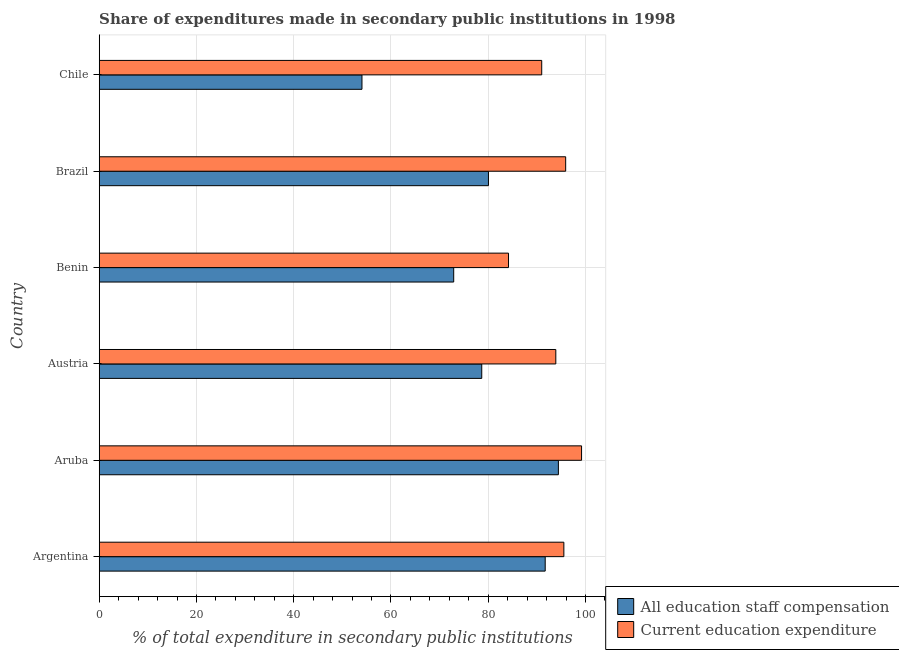How many groups of bars are there?
Your response must be concise. 6. Are the number of bars per tick equal to the number of legend labels?
Provide a short and direct response. Yes. Are the number of bars on each tick of the Y-axis equal?
Make the answer very short. Yes. How many bars are there on the 6th tick from the top?
Offer a very short reply. 2. What is the label of the 3rd group of bars from the top?
Provide a succinct answer. Benin. What is the expenditure in staff compensation in Argentina?
Offer a terse response. 91.71. Across all countries, what is the maximum expenditure in education?
Make the answer very short. 99.19. Across all countries, what is the minimum expenditure in education?
Keep it short and to the point. 84.17. In which country was the expenditure in staff compensation maximum?
Offer a terse response. Aruba. In which country was the expenditure in education minimum?
Your response must be concise. Benin. What is the total expenditure in education in the graph?
Your answer should be very brief. 559.72. What is the difference between the expenditure in education in Benin and that in Brazil?
Offer a very short reply. -11.75. What is the difference between the expenditure in education in Benin and the expenditure in staff compensation in Aruba?
Provide a short and direct response. -10.26. What is the average expenditure in staff compensation per country?
Offer a terse response. 78.63. What is the difference between the expenditure in education and expenditure in staff compensation in Aruba?
Offer a very short reply. 4.76. In how many countries, is the expenditure in staff compensation greater than 40 %?
Ensure brevity in your answer.  6. What is the ratio of the expenditure in staff compensation in Aruba to that in Chile?
Your answer should be compact. 1.75. Is the expenditure in education in Argentina less than that in Chile?
Your answer should be very brief. No. What is the difference between the highest and the second highest expenditure in staff compensation?
Give a very brief answer. 2.71. What is the difference between the highest and the lowest expenditure in staff compensation?
Provide a short and direct response. 40.39. In how many countries, is the expenditure in staff compensation greater than the average expenditure in staff compensation taken over all countries?
Provide a short and direct response. 4. What does the 1st bar from the top in Austria represents?
Give a very brief answer. Current education expenditure. What does the 1st bar from the bottom in Benin represents?
Make the answer very short. All education staff compensation. How many bars are there?
Your answer should be very brief. 12. Are all the bars in the graph horizontal?
Your answer should be very brief. Yes. Are the values on the major ticks of X-axis written in scientific E-notation?
Offer a very short reply. No. Does the graph contain any zero values?
Keep it short and to the point. No. Does the graph contain grids?
Your answer should be very brief. Yes. Where does the legend appear in the graph?
Your answer should be compact. Bottom right. What is the title of the graph?
Offer a terse response. Share of expenditures made in secondary public institutions in 1998. Does "Diarrhea" appear as one of the legend labels in the graph?
Ensure brevity in your answer.  No. What is the label or title of the X-axis?
Ensure brevity in your answer.  % of total expenditure in secondary public institutions. What is the label or title of the Y-axis?
Offer a terse response. Country. What is the % of total expenditure in secondary public institutions of All education staff compensation in Argentina?
Provide a succinct answer. 91.71. What is the % of total expenditure in secondary public institutions of Current education expenditure in Argentina?
Your answer should be very brief. 95.55. What is the % of total expenditure in secondary public institutions of All education staff compensation in Aruba?
Keep it short and to the point. 94.42. What is the % of total expenditure in secondary public institutions of Current education expenditure in Aruba?
Make the answer very short. 99.19. What is the % of total expenditure in secondary public institutions in All education staff compensation in Austria?
Make the answer very short. 78.67. What is the % of total expenditure in secondary public institutions of Current education expenditure in Austria?
Your answer should be very brief. 93.9. What is the % of total expenditure in secondary public institutions of All education staff compensation in Benin?
Give a very brief answer. 72.9. What is the % of total expenditure in secondary public institutions of Current education expenditure in Benin?
Provide a short and direct response. 84.17. What is the % of total expenditure in secondary public institutions in All education staff compensation in Brazil?
Provide a succinct answer. 80.04. What is the % of total expenditure in secondary public institutions of Current education expenditure in Brazil?
Ensure brevity in your answer.  95.92. What is the % of total expenditure in secondary public institutions in All education staff compensation in Chile?
Make the answer very short. 54.03. What is the % of total expenditure in secondary public institutions of Current education expenditure in Chile?
Your answer should be very brief. 91. Across all countries, what is the maximum % of total expenditure in secondary public institutions of All education staff compensation?
Offer a very short reply. 94.42. Across all countries, what is the maximum % of total expenditure in secondary public institutions in Current education expenditure?
Provide a succinct answer. 99.19. Across all countries, what is the minimum % of total expenditure in secondary public institutions of All education staff compensation?
Your answer should be compact. 54.03. Across all countries, what is the minimum % of total expenditure in secondary public institutions in Current education expenditure?
Offer a terse response. 84.17. What is the total % of total expenditure in secondary public institutions of All education staff compensation in the graph?
Offer a terse response. 471.77. What is the total % of total expenditure in secondary public institutions in Current education expenditure in the graph?
Your answer should be very brief. 559.72. What is the difference between the % of total expenditure in secondary public institutions in All education staff compensation in Argentina and that in Aruba?
Provide a short and direct response. -2.71. What is the difference between the % of total expenditure in secondary public institutions in Current education expenditure in Argentina and that in Aruba?
Make the answer very short. -3.64. What is the difference between the % of total expenditure in secondary public institutions of All education staff compensation in Argentina and that in Austria?
Your answer should be very brief. 13.05. What is the difference between the % of total expenditure in secondary public institutions in Current education expenditure in Argentina and that in Austria?
Provide a short and direct response. 1.65. What is the difference between the % of total expenditure in secondary public institutions of All education staff compensation in Argentina and that in Benin?
Make the answer very short. 18.82. What is the difference between the % of total expenditure in secondary public institutions in Current education expenditure in Argentina and that in Benin?
Ensure brevity in your answer.  11.38. What is the difference between the % of total expenditure in secondary public institutions of All education staff compensation in Argentina and that in Brazil?
Offer a terse response. 11.67. What is the difference between the % of total expenditure in secondary public institutions in Current education expenditure in Argentina and that in Brazil?
Provide a succinct answer. -0.37. What is the difference between the % of total expenditure in secondary public institutions of All education staff compensation in Argentina and that in Chile?
Ensure brevity in your answer.  37.68. What is the difference between the % of total expenditure in secondary public institutions in Current education expenditure in Argentina and that in Chile?
Give a very brief answer. 4.55. What is the difference between the % of total expenditure in secondary public institutions of All education staff compensation in Aruba and that in Austria?
Keep it short and to the point. 15.76. What is the difference between the % of total expenditure in secondary public institutions in Current education expenditure in Aruba and that in Austria?
Keep it short and to the point. 5.29. What is the difference between the % of total expenditure in secondary public institutions of All education staff compensation in Aruba and that in Benin?
Make the answer very short. 21.53. What is the difference between the % of total expenditure in secondary public institutions in Current education expenditure in Aruba and that in Benin?
Provide a short and direct response. 15.02. What is the difference between the % of total expenditure in secondary public institutions in All education staff compensation in Aruba and that in Brazil?
Keep it short and to the point. 14.38. What is the difference between the % of total expenditure in secondary public institutions of Current education expenditure in Aruba and that in Brazil?
Your response must be concise. 3.27. What is the difference between the % of total expenditure in secondary public institutions of All education staff compensation in Aruba and that in Chile?
Offer a very short reply. 40.39. What is the difference between the % of total expenditure in secondary public institutions in Current education expenditure in Aruba and that in Chile?
Ensure brevity in your answer.  8.19. What is the difference between the % of total expenditure in secondary public institutions in All education staff compensation in Austria and that in Benin?
Provide a short and direct response. 5.77. What is the difference between the % of total expenditure in secondary public institutions of Current education expenditure in Austria and that in Benin?
Offer a terse response. 9.73. What is the difference between the % of total expenditure in secondary public institutions of All education staff compensation in Austria and that in Brazil?
Ensure brevity in your answer.  -1.38. What is the difference between the % of total expenditure in secondary public institutions in Current education expenditure in Austria and that in Brazil?
Offer a terse response. -2.03. What is the difference between the % of total expenditure in secondary public institutions in All education staff compensation in Austria and that in Chile?
Keep it short and to the point. 24.63. What is the difference between the % of total expenditure in secondary public institutions in Current education expenditure in Austria and that in Chile?
Offer a very short reply. 2.9. What is the difference between the % of total expenditure in secondary public institutions of All education staff compensation in Benin and that in Brazil?
Give a very brief answer. -7.14. What is the difference between the % of total expenditure in secondary public institutions of Current education expenditure in Benin and that in Brazil?
Your answer should be very brief. -11.75. What is the difference between the % of total expenditure in secondary public institutions of All education staff compensation in Benin and that in Chile?
Offer a terse response. 18.86. What is the difference between the % of total expenditure in secondary public institutions in Current education expenditure in Benin and that in Chile?
Keep it short and to the point. -6.83. What is the difference between the % of total expenditure in secondary public institutions of All education staff compensation in Brazil and that in Chile?
Give a very brief answer. 26.01. What is the difference between the % of total expenditure in secondary public institutions of Current education expenditure in Brazil and that in Chile?
Ensure brevity in your answer.  4.92. What is the difference between the % of total expenditure in secondary public institutions of All education staff compensation in Argentina and the % of total expenditure in secondary public institutions of Current education expenditure in Aruba?
Make the answer very short. -7.48. What is the difference between the % of total expenditure in secondary public institutions in All education staff compensation in Argentina and the % of total expenditure in secondary public institutions in Current education expenditure in Austria?
Your answer should be very brief. -2.18. What is the difference between the % of total expenditure in secondary public institutions in All education staff compensation in Argentina and the % of total expenditure in secondary public institutions in Current education expenditure in Benin?
Offer a very short reply. 7.54. What is the difference between the % of total expenditure in secondary public institutions of All education staff compensation in Argentina and the % of total expenditure in secondary public institutions of Current education expenditure in Brazil?
Your answer should be very brief. -4.21. What is the difference between the % of total expenditure in secondary public institutions in All education staff compensation in Argentina and the % of total expenditure in secondary public institutions in Current education expenditure in Chile?
Offer a very short reply. 0.72. What is the difference between the % of total expenditure in secondary public institutions in All education staff compensation in Aruba and the % of total expenditure in secondary public institutions in Current education expenditure in Austria?
Ensure brevity in your answer.  0.53. What is the difference between the % of total expenditure in secondary public institutions in All education staff compensation in Aruba and the % of total expenditure in secondary public institutions in Current education expenditure in Benin?
Your response must be concise. 10.26. What is the difference between the % of total expenditure in secondary public institutions in All education staff compensation in Aruba and the % of total expenditure in secondary public institutions in Current education expenditure in Brazil?
Offer a terse response. -1.5. What is the difference between the % of total expenditure in secondary public institutions in All education staff compensation in Aruba and the % of total expenditure in secondary public institutions in Current education expenditure in Chile?
Provide a short and direct response. 3.43. What is the difference between the % of total expenditure in secondary public institutions in All education staff compensation in Austria and the % of total expenditure in secondary public institutions in Current education expenditure in Benin?
Give a very brief answer. -5.5. What is the difference between the % of total expenditure in secondary public institutions in All education staff compensation in Austria and the % of total expenditure in secondary public institutions in Current education expenditure in Brazil?
Your answer should be compact. -17.26. What is the difference between the % of total expenditure in secondary public institutions of All education staff compensation in Austria and the % of total expenditure in secondary public institutions of Current education expenditure in Chile?
Your answer should be compact. -12.33. What is the difference between the % of total expenditure in secondary public institutions of All education staff compensation in Benin and the % of total expenditure in secondary public institutions of Current education expenditure in Brazil?
Offer a very short reply. -23.02. What is the difference between the % of total expenditure in secondary public institutions in All education staff compensation in Benin and the % of total expenditure in secondary public institutions in Current education expenditure in Chile?
Your answer should be compact. -18.1. What is the difference between the % of total expenditure in secondary public institutions of All education staff compensation in Brazil and the % of total expenditure in secondary public institutions of Current education expenditure in Chile?
Provide a short and direct response. -10.96. What is the average % of total expenditure in secondary public institutions in All education staff compensation per country?
Keep it short and to the point. 78.63. What is the average % of total expenditure in secondary public institutions in Current education expenditure per country?
Offer a very short reply. 93.29. What is the difference between the % of total expenditure in secondary public institutions in All education staff compensation and % of total expenditure in secondary public institutions in Current education expenditure in Argentina?
Give a very brief answer. -3.84. What is the difference between the % of total expenditure in secondary public institutions of All education staff compensation and % of total expenditure in secondary public institutions of Current education expenditure in Aruba?
Keep it short and to the point. -4.77. What is the difference between the % of total expenditure in secondary public institutions of All education staff compensation and % of total expenditure in secondary public institutions of Current education expenditure in Austria?
Offer a terse response. -15.23. What is the difference between the % of total expenditure in secondary public institutions in All education staff compensation and % of total expenditure in secondary public institutions in Current education expenditure in Benin?
Your response must be concise. -11.27. What is the difference between the % of total expenditure in secondary public institutions of All education staff compensation and % of total expenditure in secondary public institutions of Current education expenditure in Brazil?
Your answer should be very brief. -15.88. What is the difference between the % of total expenditure in secondary public institutions of All education staff compensation and % of total expenditure in secondary public institutions of Current education expenditure in Chile?
Your answer should be very brief. -36.97. What is the ratio of the % of total expenditure in secondary public institutions of All education staff compensation in Argentina to that in Aruba?
Give a very brief answer. 0.97. What is the ratio of the % of total expenditure in secondary public institutions of Current education expenditure in Argentina to that in Aruba?
Your answer should be compact. 0.96. What is the ratio of the % of total expenditure in secondary public institutions of All education staff compensation in Argentina to that in Austria?
Keep it short and to the point. 1.17. What is the ratio of the % of total expenditure in secondary public institutions in Current education expenditure in Argentina to that in Austria?
Your answer should be very brief. 1.02. What is the ratio of the % of total expenditure in secondary public institutions of All education staff compensation in Argentina to that in Benin?
Your response must be concise. 1.26. What is the ratio of the % of total expenditure in secondary public institutions in Current education expenditure in Argentina to that in Benin?
Offer a terse response. 1.14. What is the ratio of the % of total expenditure in secondary public institutions of All education staff compensation in Argentina to that in Brazil?
Offer a terse response. 1.15. What is the ratio of the % of total expenditure in secondary public institutions of All education staff compensation in Argentina to that in Chile?
Your answer should be compact. 1.7. What is the ratio of the % of total expenditure in secondary public institutions in Current education expenditure in Argentina to that in Chile?
Provide a succinct answer. 1.05. What is the ratio of the % of total expenditure in secondary public institutions of All education staff compensation in Aruba to that in Austria?
Your answer should be very brief. 1.2. What is the ratio of the % of total expenditure in secondary public institutions of Current education expenditure in Aruba to that in Austria?
Provide a short and direct response. 1.06. What is the ratio of the % of total expenditure in secondary public institutions of All education staff compensation in Aruba to that in Benin?
Keep it short and to the point. 1.3. What is the ratio of the % of total expenditure in secondary public institutions of Current education expenditure in Aruba to that in Benin?
Your answer should be very brief. 1.18. What is the ratio of the % of total expenditure in secondary public institutions in All education staff compensation in Aruba to that in Brazil?
Your response must be concise. 1.18. What is the ratio of the % of total expenditure in secondary public institutions in Current education expenditure in Aruba to that in Brazil?
Your response must be concise. 1.03. What is the ratio of the % of total expenditure in secondary public institutions of All education staff compensation in Aruba to that in Chile?
Provide a short and direct response. 1.75. What is the ratio of the % of total expenditure in secondary public institutions in Current education expenditure in Aruba to that in Chile?
Your answer should be very brief. 1.09. What is the ratio of the % of total expenditure in secondary public institutions in All education staff compensation in Austria to that in Benin?
Give a very brief answer. 1.08. What is the ratio of the % of total expenditure in secondary public institutions in Current education expenditure in Austria to that in Benin?
Your answer should be compact. 1.12. What is the ratio of the % of total expenditure in secondary public institutions in All education staff compensation in Austria to that in Brazil?
Your answer should be compact. 0.98. What is the ratio of the % of total expenditure in secondary public institutions of Current education expenditure in Austria to that in Brazil?
Make the answer very short. 0.98. What is the ratio of the % of total expenditure in secondary public institutions in All education staff compensation in Austria to that in Chile?
Make the answer very short. 1.46. What is the ratio of the % of total expenditure in secondary public institutions in Current education expenditure in Austria to that in Chile?
Give a very brief answer. 1.03. What is the ratio of the % of total expenditure in secondary public institutions in All education staff compensation in Benin to that in Brazil?
Keep it short and to the point. 0.91. What is the ratio of the % of total expenditure in secondary public institutions in Current education expenditure in Benin to that in Brazil?
Keep it short and to the point. 0.88. What is the ratio of the % of total expenditure in secondary public institutions in All education staff compensation in Benin to that in Chile?
Offer a very short reply. 1.35. What is the ratio of the % of total expenditure in secondary public institutions of Current education expenditure in Benin to that in Chile?
Your response must be concise. 0.93. What is the ratio of the % of total expenditure in secondary public institutions of All education staff compensation in Brazil to that in Chile?
Your answer should be very brief. 1.48. What is the ratio of the % of total expenditure in secondary public institutions in Current education expenditure in Brazil to that in Chile?
Your answer should be compact. 1.05. What is the difference between the highest and the second highest % of total expenditure in secondary public institutions of All education staff compensation?
Your answer should be very brief. 2.71. What is the difference between the highest and the second highest % of total expenditure in secondary public institutions of Current education expenditure?
Give a very brief answer. 3.27. What is the difference between the highest and the lowest % of total expenditure in secondary public institutions in All education staff compensation?
Provide a short and direct response. 40.39. What is the difference between the highest and the lowest % of total expenditure in secondary public institutions in Current education expenditure?
Your answer should be very brief. 15.02. 